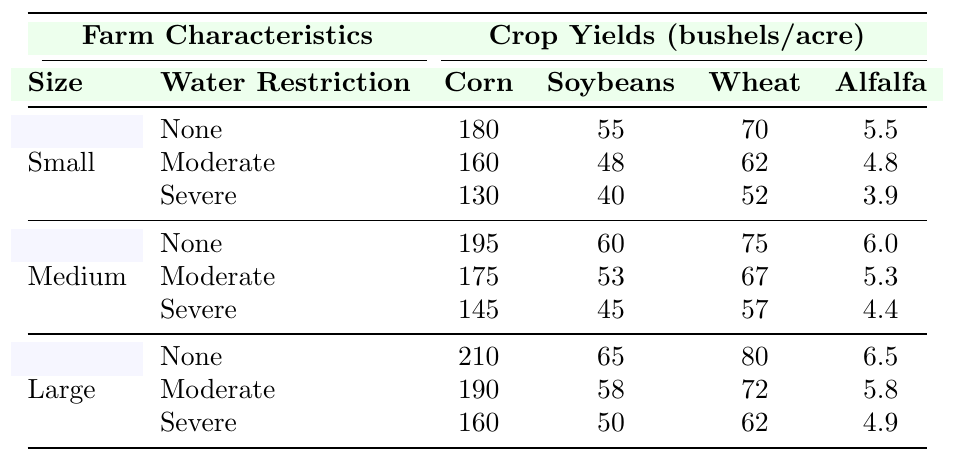What is the corn yield for small farms under moderate water restrictions? According to the table, the corn yield for small farms under moderate water restrictions is directly listed as 160 bushels per acre.
Answer: 160 What is the soybean yield for medium-sized farms with severe restrictions compared to those with no restrictions? The soybean yield for medium-sized farms with severe restrictions is 45 bushels per acre, while with no restrictions, it is 60 bushels per acre. The difference is 60 - 45 = 15 bushels per acre.
Answer: 15 For large farms, how much does the wheat yield decrease from no restrictions to severe restrictions? The wheat yield for large farms under no restrictions is 80 bushels per acre and under severe restrictions is 62 bushels per acre. The decrease in yield is calculated as 80 - 62 = 18 bushels per acre.
Answer: 18 What crop has the highest yield in small farms under no water restrictions? In small farms with no water restrictions, corn has the highest yield at 180 bushels per acre, compared to soybeans, wheat, and alfalfa.
Answer: Corn What is the average corn yield across all farm sizes when there are no water restrictions? For no restrictions, the corn yields are as follows: small farms 180, medium farms 195, and large farms 210. The average is calculated as (180 + 195 + 210) / 3 = 585 / 3 = 195 bushels per acre.
Answer: 195 For medium-sized farms, which crop experiences the largest yield reduction from no water restrictions to severe restrictions? The yields under no restrictions for medium-sized farms are: corn 195, soybeans 60, wheat 75, and alfalfa 6.0. Under severe restrictions, the yields are: corn 145, soybeans 45, wheat 57, and alfalfa 4.4. The reductions are: corn (195 - 145 = 50), soybeans (60 - 45 = 15), wheat (75 - 57 = 18), and alfalfa (6.0 - 4.4 = 1.6). The largest reduction is for corn at 50 bushels per acre.
Answer: Corn Is there a difference in alfalfa yield between small and large farms when there are moderate restrictions? For small farms under moderate restrictions, the alfalfa yield is 4.8 bushels per acre, while for large farms, it is 5.8 bushels per acre. There is a difference of 5.8 - 4.8 = 1 bushel per acre, indicating that large farms have a higher yield.
Answer: Yes What is the total yield of all crops combined for medium farms with moderate water restrictions? For medium farms under moderate restrictions, the yields are: corn 175, soybeans 53, wheat 67, and alfalfa 5.3. The total yield is calculated as: 175 + 53 + 67 + 5.3 = 300.3 bushels per acre.
Answer: 300.3 